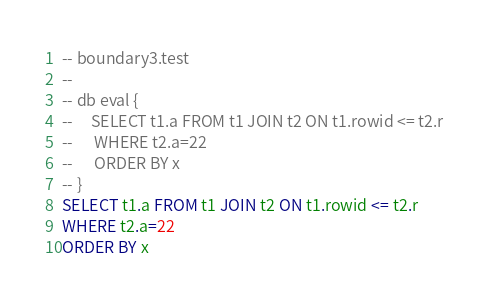<code> <loc_0><loc_0><loc_500><loc_500><_SQL_>-- boundary3.test
-- 
-- db eval {
--     SELECT t1.a FROM t1 JOIN t2 ON t1.rowid <= t2.r
--      WHERE t2.a=22
--      ORDER BY x
-- }
SELECT t1.a FROM t1 JOIN t2 ON t1.rowid <= t2.r
WHERE t2.a=22
ORDER BY x</code> 